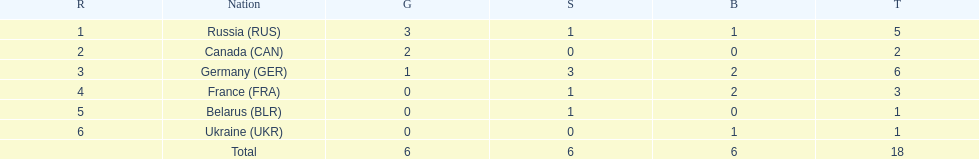Which countries received gold medals? Russia (RUS), Canada (CAN), Germany (GER). Of these countries, which did not receive a silver medal? Canada (CAN). 